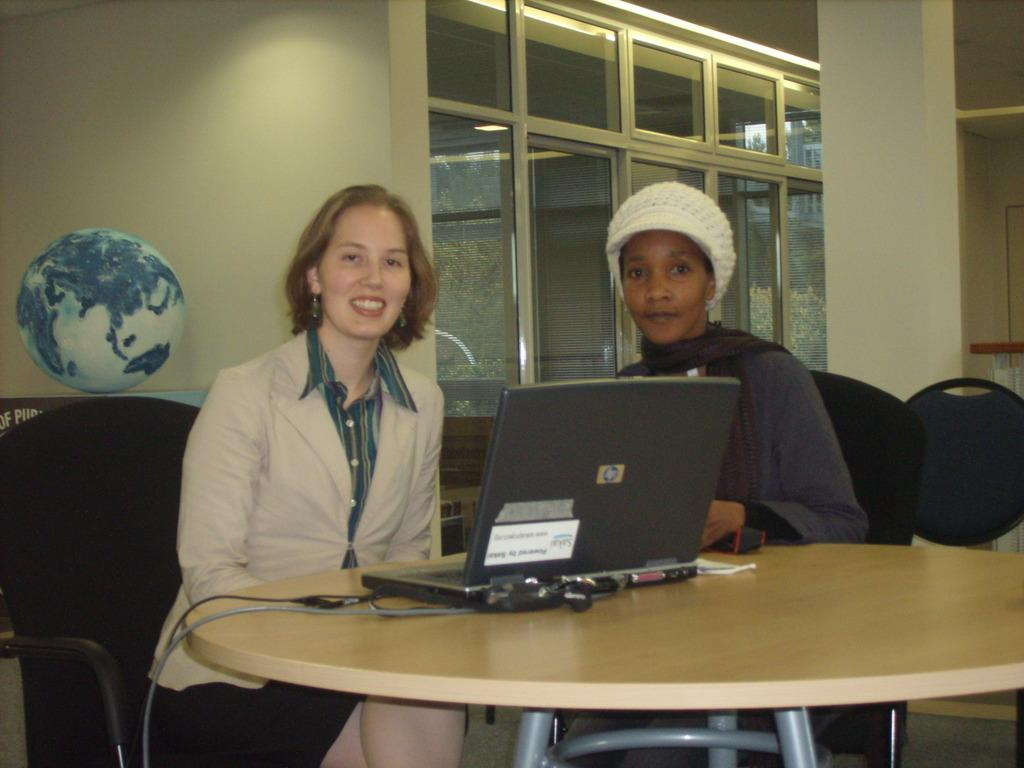How many women are in the image? There are two women in the image. What are the women doing in the image? The women are sitting on chairs. What is on the table in the image? A laptop is on the table. What additional object can be seen in the image? There is a globe in the image. What type of structure is visible in the image? There is a wall in the image. What feature allows for a view of the outdoors? There is a glass door in the image. What color are the stockings worn by the women in the image? There is no information about stockings or any clothing worn by the women in the image. 